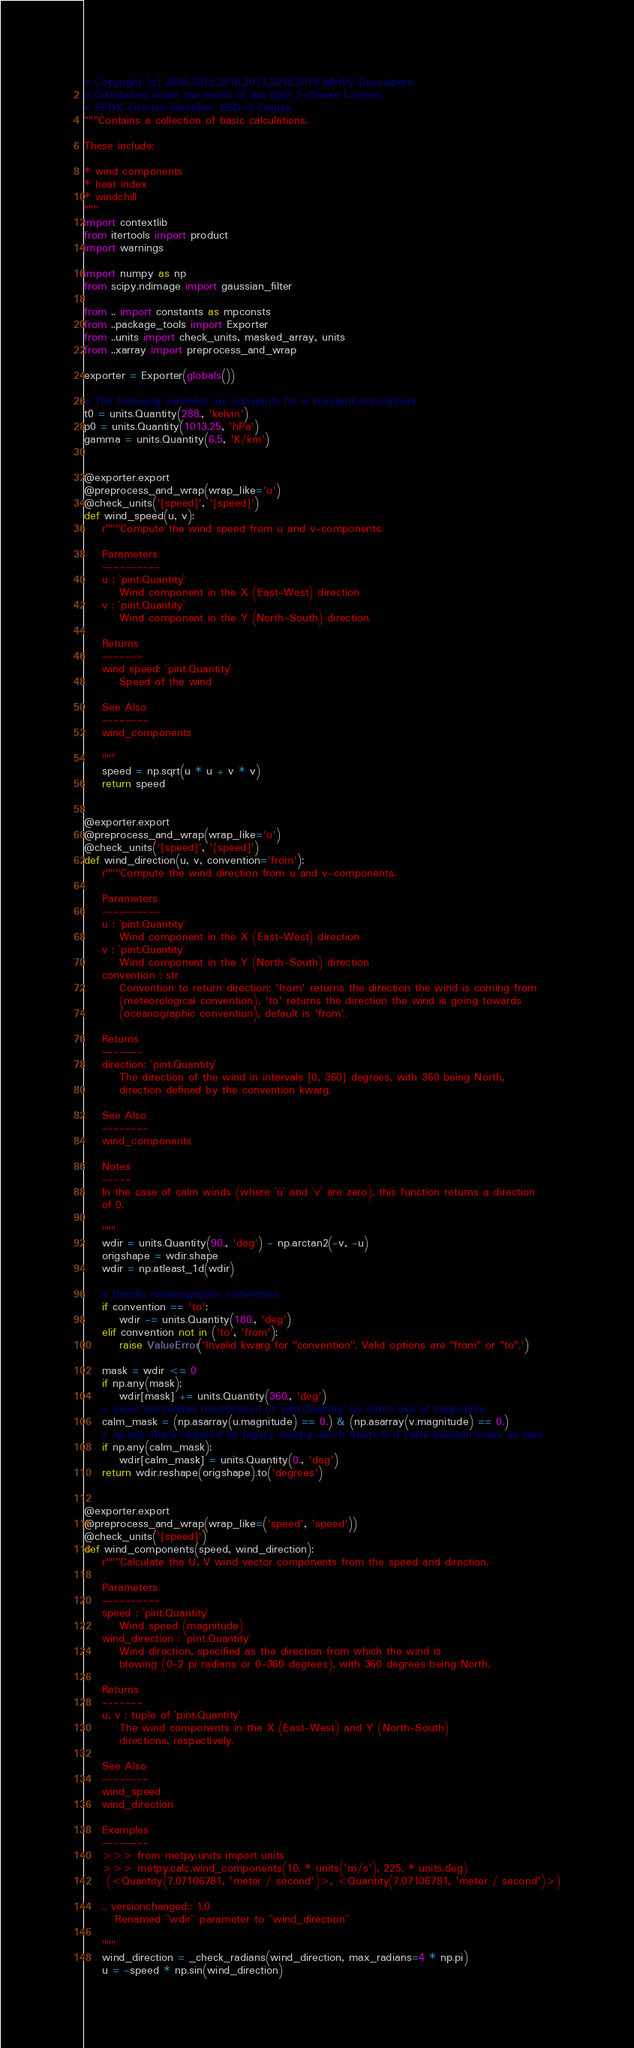Convert code to text. <code><loc_0><loc_0><loc_500><loc_500><_Python_># Copyright (c) 2008,2015,2016,2017,2018,2019 MetPy Developers.
# Distributed under the terms of the BSD 3-Clause License.
# SPDX-License-Identifier: BSD-3-Clause
"""Contains a collection of basic calculations.

These include:

* wind components
* heat index
* windchill
"""
import contextlib
from itertools import product
import warnings

import numpy as np
from scipy.ndimage import gaussian_filter

from .. import constants as mpconsts
from ..package_tools import Exporter
from ..units import check_units, masked_array, units
from ..xarray import preprocess_and_wrap

exporter = Exporter(globals())

# The following variables are constants for a standard atmosphere
t0 = units.Quantity(288., 'kelvin')
p0 = units.Quantity(1013.25, 'hPa')
gamma = units.Quantity(6.5, 'K/km')


@exporter.export
@preprocess_and_wrap(wrap_like='u')
@check_units('[speed]', '[speed]')
def wind_speed(u, v):
    r"""Compute the wind speed from u and v-components.

    Parameters
    ----------
    u : `pint.Quantity`
        Wind component in the X (East-West) direction
    v : `pint.Quantity`
        Wind component in the Y (North-South) direction

    Returns
    -------
    wind speed: `pint.Quantity`
        Speed of the wind

    See Also
    --------
    wind_components

    """
    speed = np.sqrt(u * u + v * v)
    return speed


@exporter.export
@preprocess_and_wrap(wrap_like='u')
@check_units('[speed]', '[speed]')
def wind_direction(u, v, convention='from'):
    r"""Compute the wind direction from u and v-components.

    Parameters
    ----------
    u : `pint.Quantity`
        Wind component in the X (East-West) direction
    v : `pint.Quantity`
        Wind component in the Y (North-South) direction
    convention : str
        Convention to return direction; 'from' returns the direction the wind is coming from
        (meteorological convention), 'to' returns the direction the wind is going towards
        (oceanographic convention), default is 'from'.

    Returns
    -------
    direction: `pint.Quantity`
        The direction of the wind in intervals [0, 360] degrees, with 360 being North,
        direction defined by the convention kwarg.

    See Also
    --------
    wind_components

    Notes
    -----
    In the case of calm winds (where `u` and `v` are zero), this function returns a direction
    of 0.

    """
    wdir = units.Quantity(90., 'deg') - np.arctan2(-v, -u)
    origshape = wdir.shape
    wdir = np.atleast_1d(wdir)

    # Handle oceanographic convection
    if convention == 'to':
        wdir -= units.Quantity(180., 'deg')
    elif convention not in ('to', 'from'):
        raise ValueError('Invalid kwarg for "convention". Valid options are "from" or "to".')

    mask = wdir <= 0
    if np.any(mask):
        wdir[mask] += units.Quantity(360., 'deg')
    # avoid unintended modification of `pint.Quantity` by direct use of magnitude
    calm_mask = (np.asarray(u.magnitude) == 0.) & (np.asarray(v.magnitude) == 0.)
    # np.any check required for legacy numpy which treats 0-d False boolean index as zero
    if np.any(calm_mask):
        wdir[calm_mask] = units.Quantity(0., 'deg')
    return wdir.reshape(origshape).to('degrees')


@exporter.export
@preprocess_and_wrap(wrap_like=('speed', 'speed'))
@check_units('[speed]')
def wind_components(speed, wind_direction):
    r"""Calculate the U, V wind vector components from the speed and direction.

    Parameters
    ----------
    speed : `pint.Quantity`
        Wind speed (magnitude)
    wind_direction : `pint.Quantity`
        Wind direction, specified as the direction from which the wind is
        blowing (0-2 pi radians or 0-360 degrees), with 360 degrees being North.

    Returns
    -------
    u, v : tuple of `pint.Quantity`
        The wind components in the X (East-West) and Y (North-South)
        directions, respectively.

    See Also
    --------
    wind_speed
    wind_direction

    Examples
    --------
    >>> from metpy.units import units
    >>> metpy.calc.wind_components(10. * units('m/s'), 225. * units.deg)
     (<Quantity(7.07106781, 'meter / second')>, <Quantity(7.07106781, 'meter / second')>)

    .. versionchanged:: 1.0
       Renamed ``wdir`` parameter to ``wind_direction``

    """
    wind_direction = _check_radians(wind_direction, max_radians=4 * np.pi)
    u = -speed * np.sin(wind_direction)</code> 